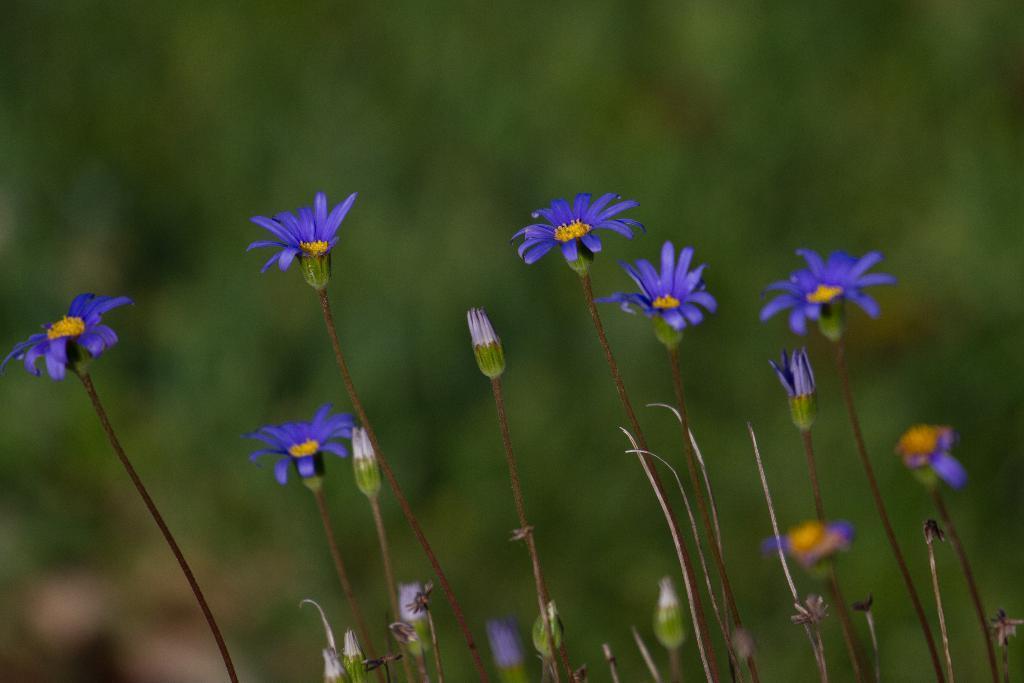Describe this image in one or two sentences. In this image there are flowers and buds to the stems. The background is blurry. 